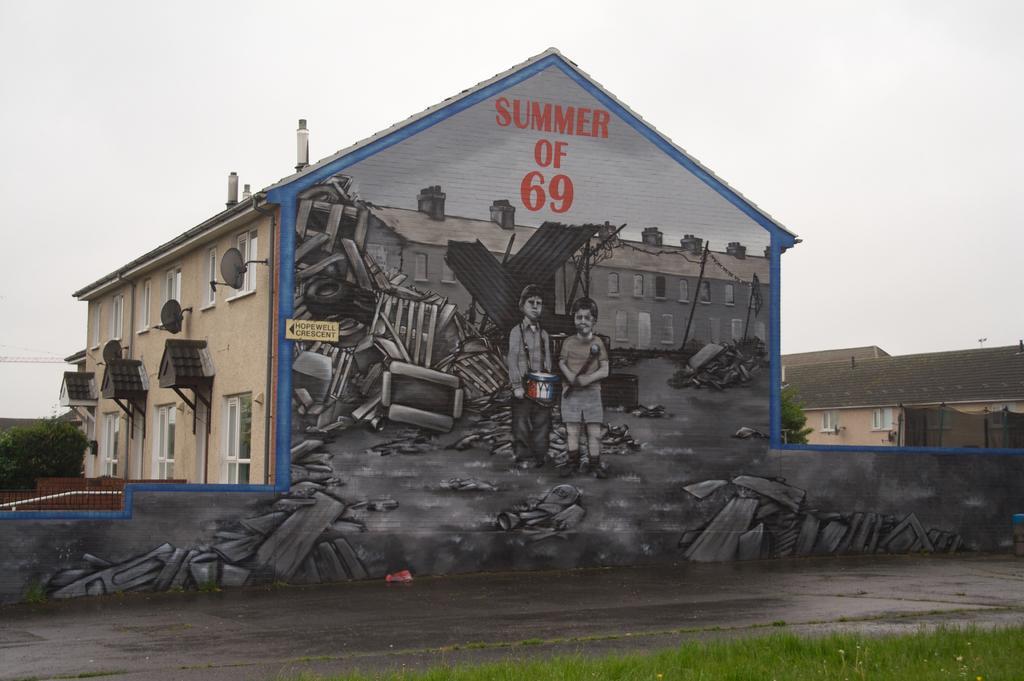Can you describe this image briefly? There is a painting of two children, woods, buildings, sky and other objects on the wall of a building which is having windows. Beside this wall, there is a road, beside this road, there is grass on the ground. In the background, there is a building having a roof, there are trees and there are clouds in the sky. 